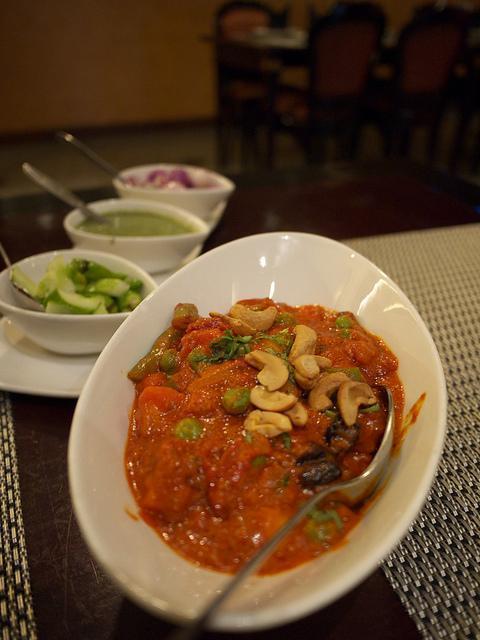How many bowls are in the picture?
Give a very brief answer. 4. How many utensils are in this picture?
Give a very brief answer. 4. How many chairs are there?
Give a very brief answer. 3. How many bowls are there?
Give a very brief answer. 4. How many dining tables can you see?
Give a very brief answer. 2. How many trucks are there?
Give a very brief answer. 0. 